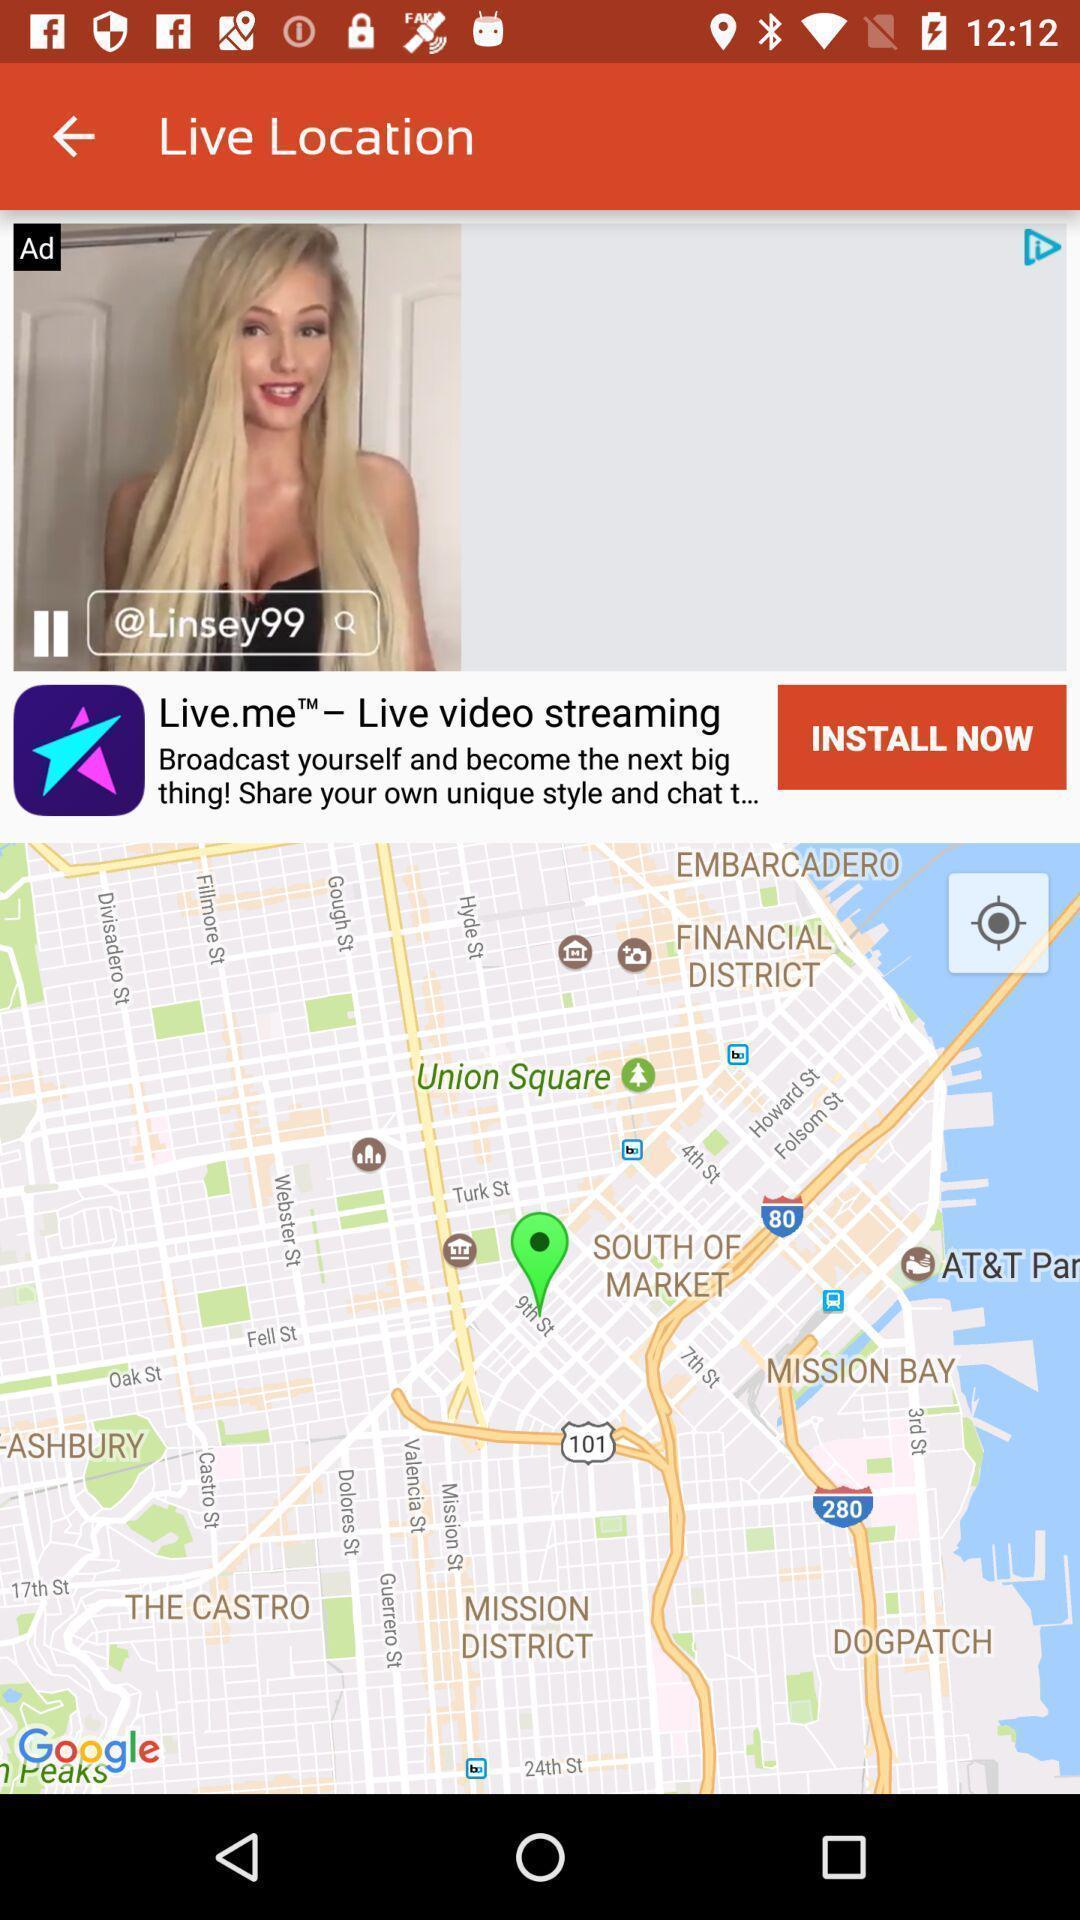What can you discern from this picture? Screen shows live location details. 